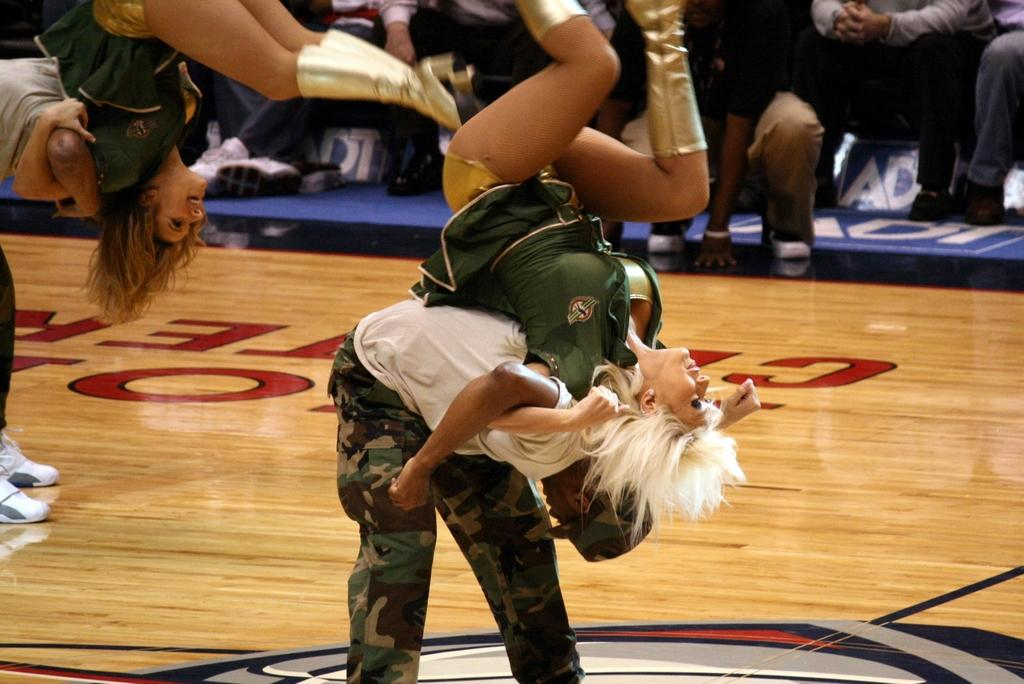What is happening in the center of the image? There are people performing in the center of the image. How can you describe the appearance of the performers? The performers are wearing different costumes. What can be seen in the background of the image? There are banners in the background of the image. Are there any other people visible in the image? Yes, there are people sitting in the background of the image. Can you tell me how many bees are buzzing around the performers in the image? There are no bees present in the image; the focus is on the performers and their costumes. What type of pets can be seen accompanying the people sitting in the background? There are no pets visible in the image; the focus is on the people and their seating arrangement. 